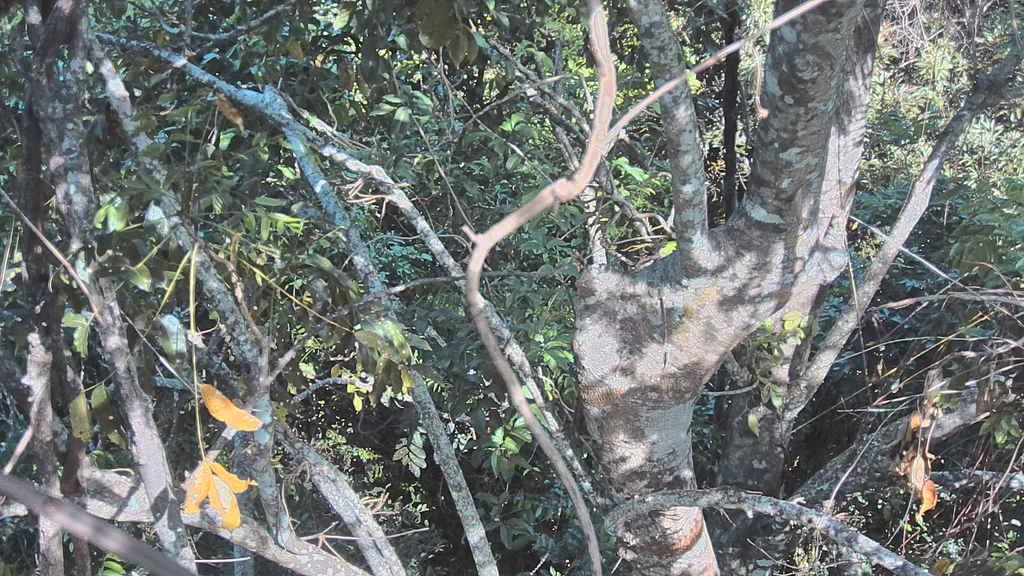What type of vegetation can be seen in the image? There are trees and plants in the image. What parts of the vegetation are visible in the image? Leaves and stems are visible in the image. What is the income of the thought in the image? There is no thought or income present in the image; it features trees and plants. 